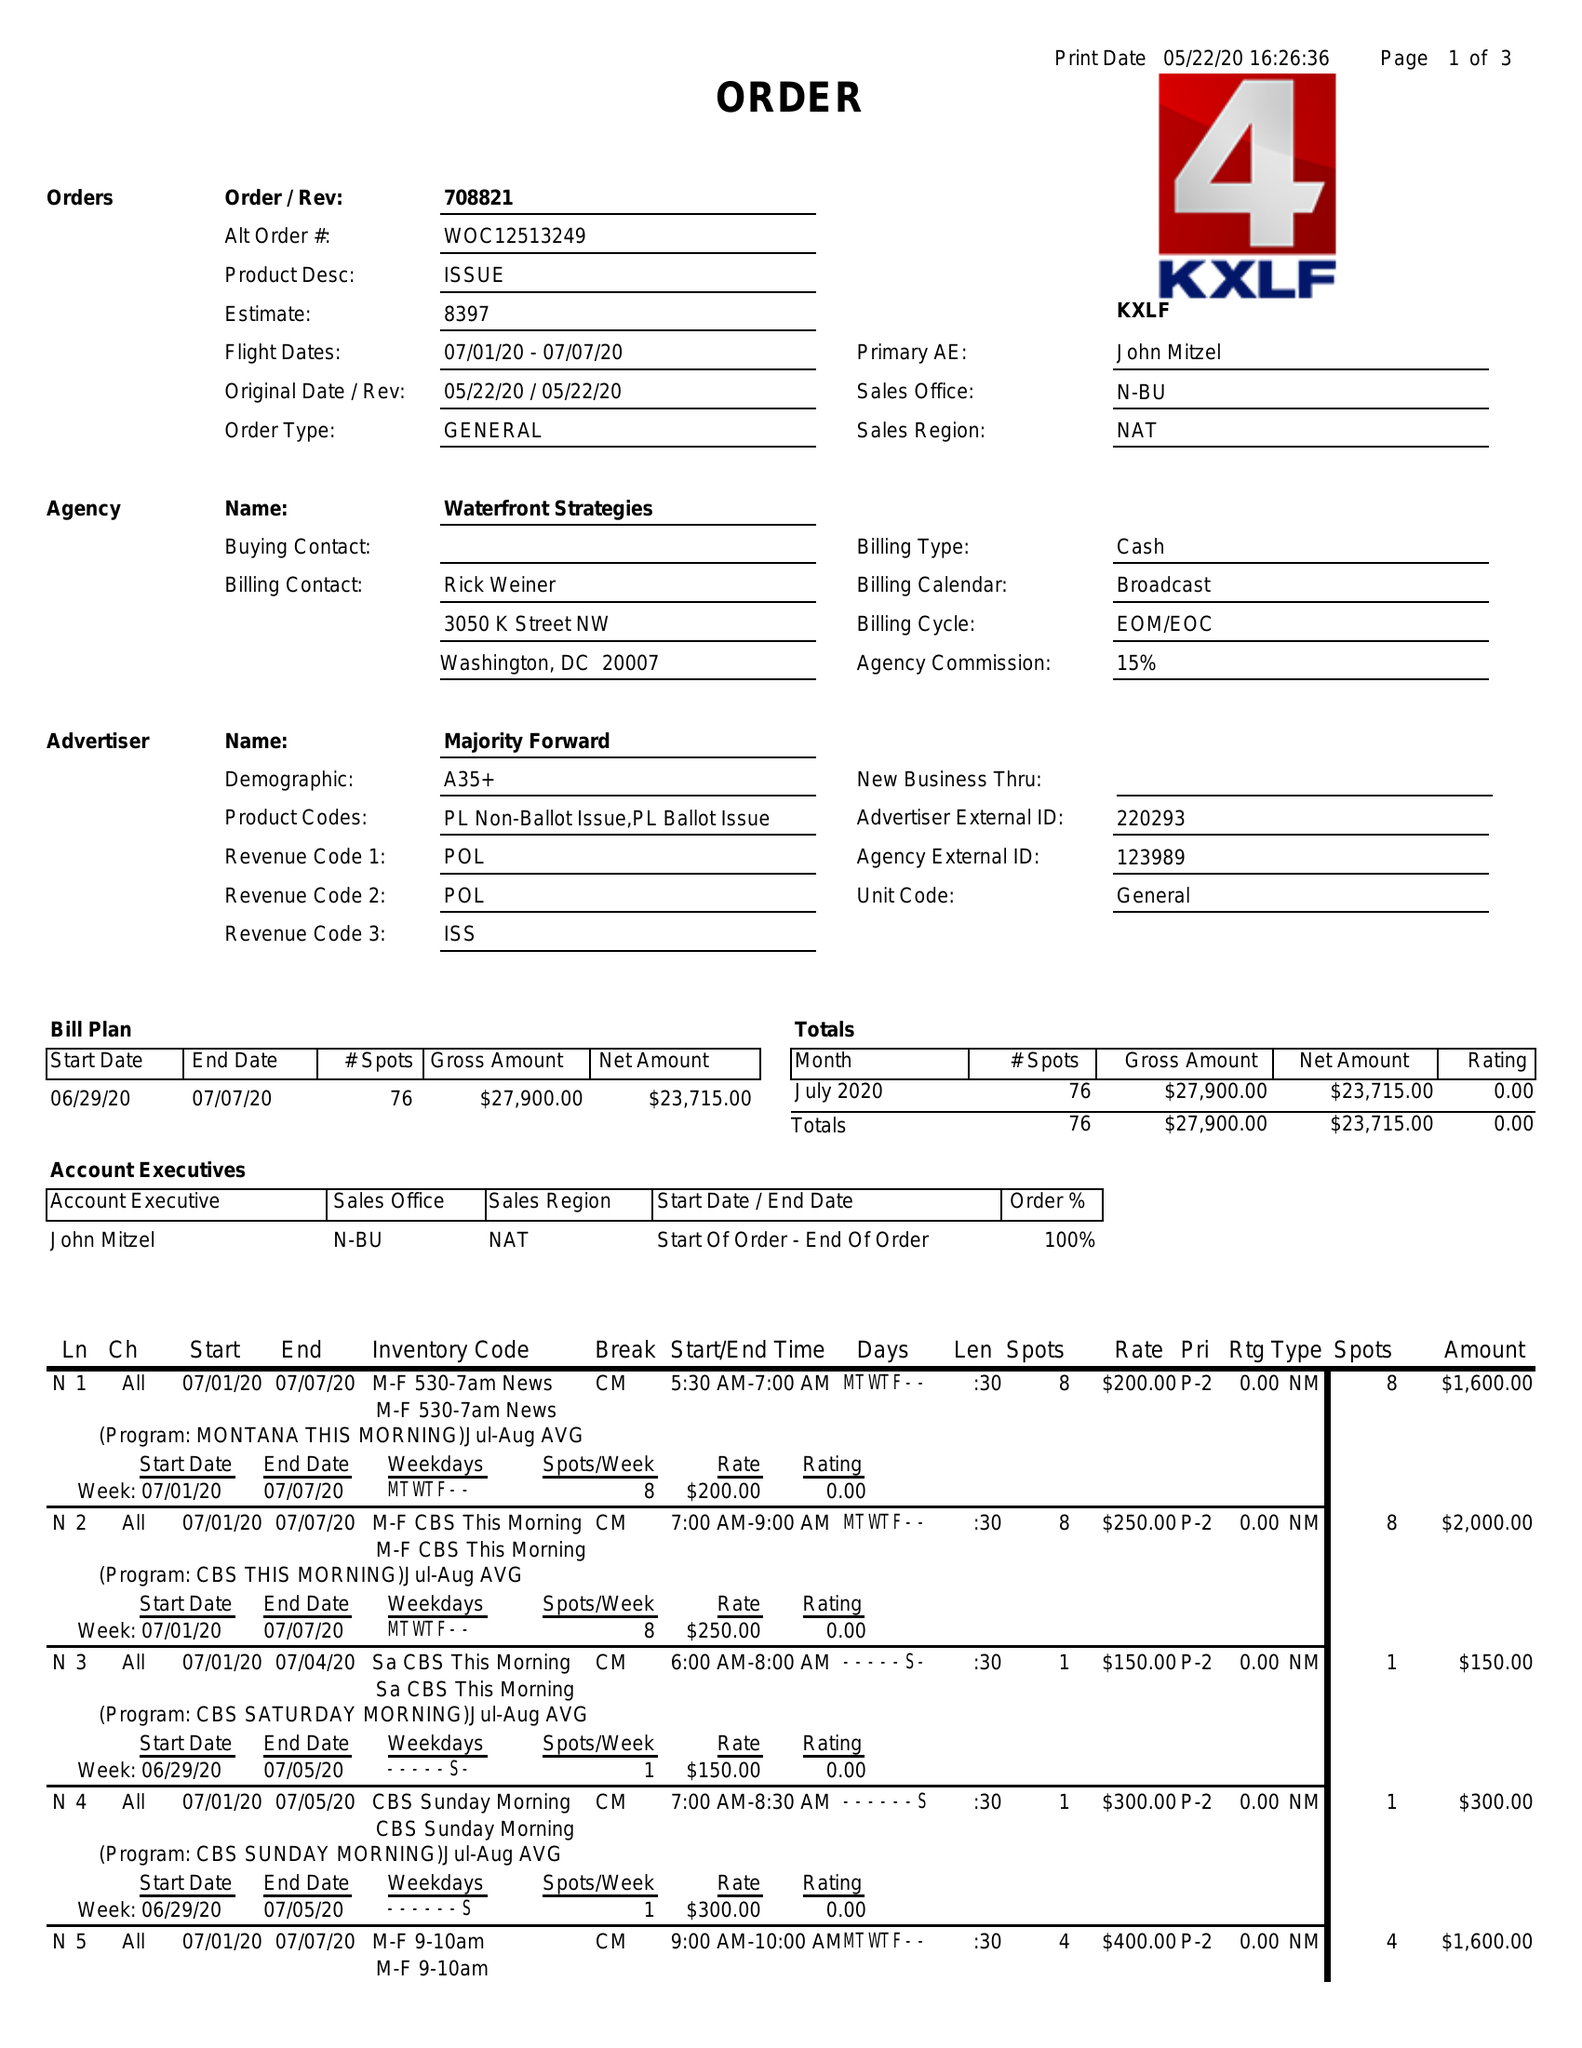What is the value for the advertiser?
Answer the question using a single word or phrase. MAJORITY FORWARD 